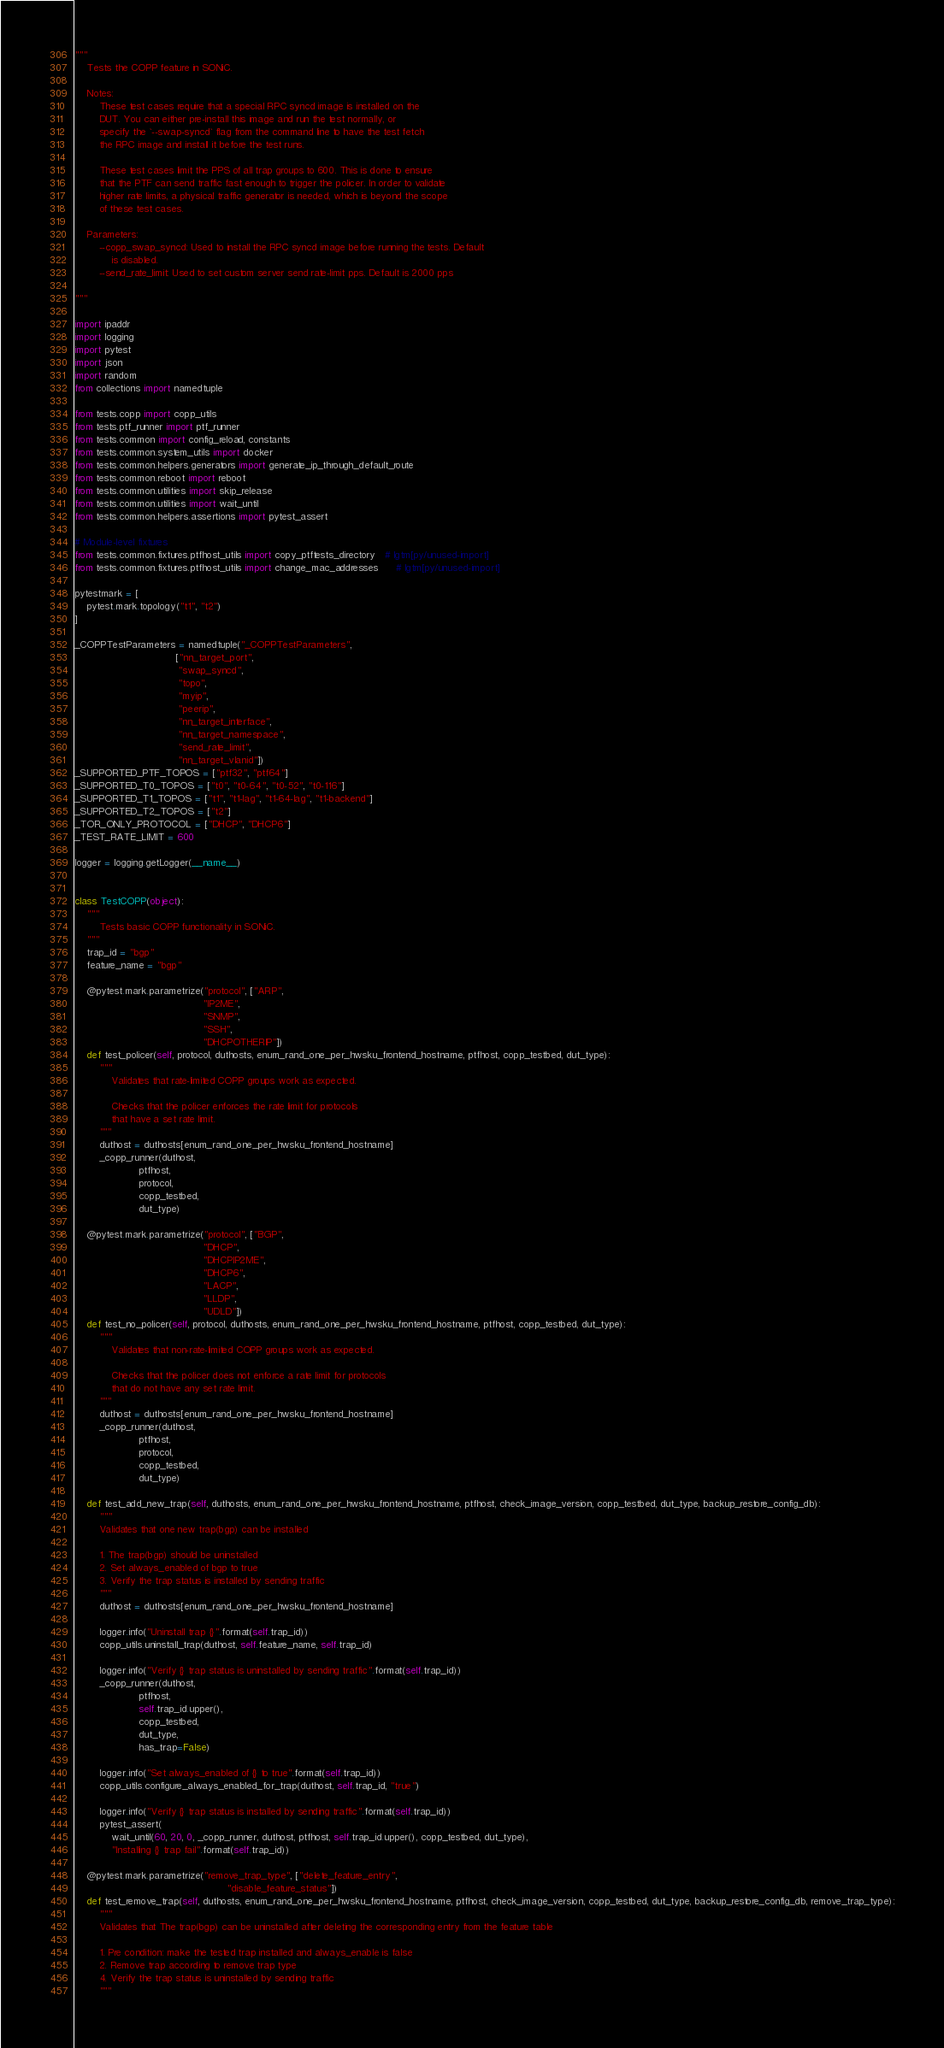Convert code to text. <code><loc_0><loc_0><loc_500><loc_500><_Python_>"""
    Tests the COPP feature in SONiC.

    Notes:
        These test cases require that a special RPC syncd image is installed on the
        DUT. You can either pre-install this image and run the test normally, or
        specify the `--swap-syncd` flag from the command line to have the test fetch
        the RPC image and install it before the test runs.

        These test cases limit the PPS of all trap groups to 600. This is done to ensure
        that the PTF can send traffic fast enough to trigger the policer. In order to validate
        higher rate limits, a physical traffic generator is needed, which is beyond the scope
        of these test cases.

    Parameters:
        --copp_swap_syncd: Used to install the RPC syncd image before running the tests. Default
            is disabled.
        --send_rate_limit: Used to set custom server send rate-limit pps. Default is 2000 pps

"""

import ipaddr
import logging
import pytest
import json
import random
from collections import namedtuple

from tests.copp import copp_utils
from tests.ptf_runner import ptf_runner
from tests.common import config_reload, constants
from tests.common.system_utils import docker
from tests.common.helpers.generators import generate_ip_through_default_route
from tests.common.reboot import reboot
from tests.common.utilities import skip_release
from tests.common.utilities import wait_until
from tests.common.helpers.assertions import pytest_assert

# Module-level fixtures
from tests.common.fixtures.ptfhost_utils import copy_ptftests_directory   # lgtm[py/unused-import]
from tests.common.fixtures.ptfhost_utils import change_mac_addresses      # lgtm[py/unused-import]

pytestmark = [
    pytest.mark.topology("t1", "t2")
]

_COPPTestParameters = namedtuple("_COPPTestParameters",
                                 ["nn_target_port",
                                  "swap_syncd",
                                  "topo",
                                  "myip",
                                  "peerip",
                                  "nn_target_interface",
                                  "nn_target_namespace",
                                  "send_rate_limit",
                                  "nn_target_vlanid"])
_SUPPORTED_PTF_TOPOS = ["ptf32", "ptf64"]
_SUPPORTED_T0_TOPOS = ["t0", "t0-64", "t0-52", "t0-116"]
_SUPPORTED_T1_TOPOS = ["t1", "t1-lag", "t1-64-lag", "t1-backend"]
_SUPPORTED_T2_TOPOS = ["t2"]
_TOR_ONLY_PROTOCOL = ["DHCP", "DHCP6"]
_TEST_RATE_LIMIT = 600

logger = logging.getLogger(__name__)


class TestCOPP(object):
    """
        Tests basic COPP functionality in SONiC.
    """
    trap_id = "bgp"
    feature_name = "bgp"

    @pytest.mark.parametrize("protocol", ["ARP",
                                          "IP2ME",
                                          "SNMP",
                                          "SSH",
                                          "DHCPOTHERIP"])
    def test_policer(self, protocol, duthosts, enum_rand_one_per_hwsku_frontend_hostname, ptfhost, copp_testbed, dut_type):
        """
            Validates that rate-limited COPP groups work as expected.

            Checks that the policer enforces the rate limit for protocols
            that have a set rate limit.
        """
        duthost = duthosts[enum_rand_one_per_hwsku_frontend_hostname]
        _copp_runner(duthost,
                     ptfhost,
                     protocol,
                     copp_testbed,
                     dut_type)

    @pytest.mark.parametrize("protocol", ["BGP",
                                          "DHCP",
                                          "DHCPIP2ME",
                                          "DHCP6",
                                          "LACP",
                                          "LLDP",
                                          "UDLD"])
    def test_no_policer(self, protocol, duthosts, enum_rand_one_per_hwsku_frontend_hostname, ptfhost, copp_testbed, dut_type):
        """
            Validates that non-rate-limited COPP groups work as expected.

            Checks that the policer does not enforce a rate limit for protocols
            that do not have any set rate limit.
        """
        duthost = duthosts[enum_rand_one_per_hwsku_frontend_hostname]
        _copp_runner(duthost,
                     ptfhost,
                     protocol,
                     copp_testbed,
                     dut_type)

    def test_add_new_trap(self, duthosts, enum_rand_one_per_hwsku_frontend_hostname, ptfhost, check_image_version, copp_testbed, dut_type, backup_restore_config_db):
        """
        Validates that one new trap(bgp) can be installed

        1. The trap(bgp) should be uninstalled
        2. Set always_enabled of bgp to true
        3. Verify the trap status is installed by sending traffic
        """
        duthost = duthosts[enum_rand_one_per_hwsku_frontend_hostname]

        logger.info("Uninstall trap {}".format(self.trap_id))
        copp_utils.uninstall_trap(duthost, self.feature_name, self.trap_id)

        logger.info("Verify {} trap status is uninstalled by sending traffic".format(self.trap_id))
        _copp_runner(duthost,
                     ptfhost,
                     self.trap_id.upper(),
                     copp_testbed,
                     dut_type,
                     has_trap=False)

        logger.info("Set always_enabled of {} to true".format(self.trap_id))
        copp_utils.configure_always_enabled_for_trap(duthost, self.trap_id, "true")

        logger.info("Verify {} trap status is installed by sending traffic".format(self.trap_id))
        pytest_assert(
            wait_until(60, 20, 0, _copp_runner, duthost, ptfhost, self.trap_id.upper(), copp_testbed, dut_type),
            "Installing {} trap fail".format(self.trap_id))

    @pytest.mark.parametrize("remove_trap_type", ["delete_feature_entry",
                                                  "disable_feature_status"])
    def test_remove_trap(self, duthosts, enum_rand_one_per_hwsku_frontend_hostname, ptfhost, check_image_version, copp_testbed, dut_type, backup_restore_config_db, remove_trap_type):
        """
        Validates that The trap(bgp) can be uninstalled after deleting the corresponding entry from the feature table

        1. Pre condition: make the tested trap installed and always_enable is false
        2. Remove trap according to remove trap type
        4. Verify the trap status is uninstalled by sending traffic
        """</code> 